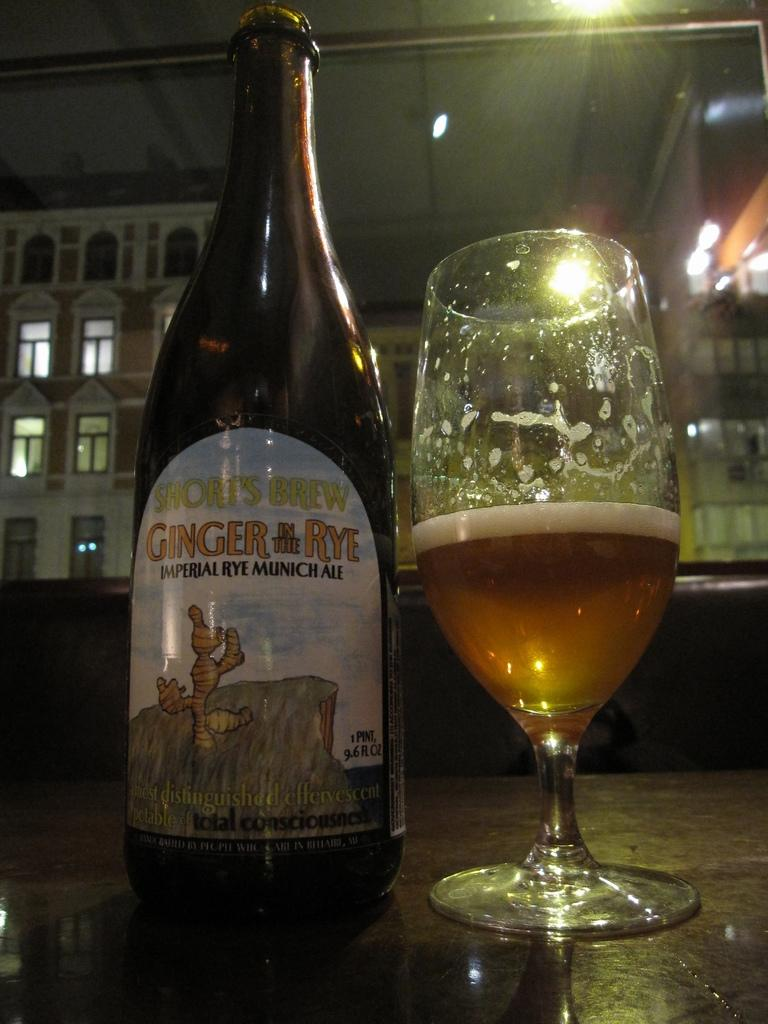What type of container is present in the image? There is a bottle in the image. What other type of container is present in the image? There is a wine glass in the image. Where are the bottle and wine glass located? Both the bottle and the wine glass are on a table. What can be seen in the background of the image? There are buildings visible in the image. What book is being read in the image? There is no book present in the image. How does the bottle provide comfort in the image? The bottle does not provide comfort in the image; it is simply a container for a liquid. 